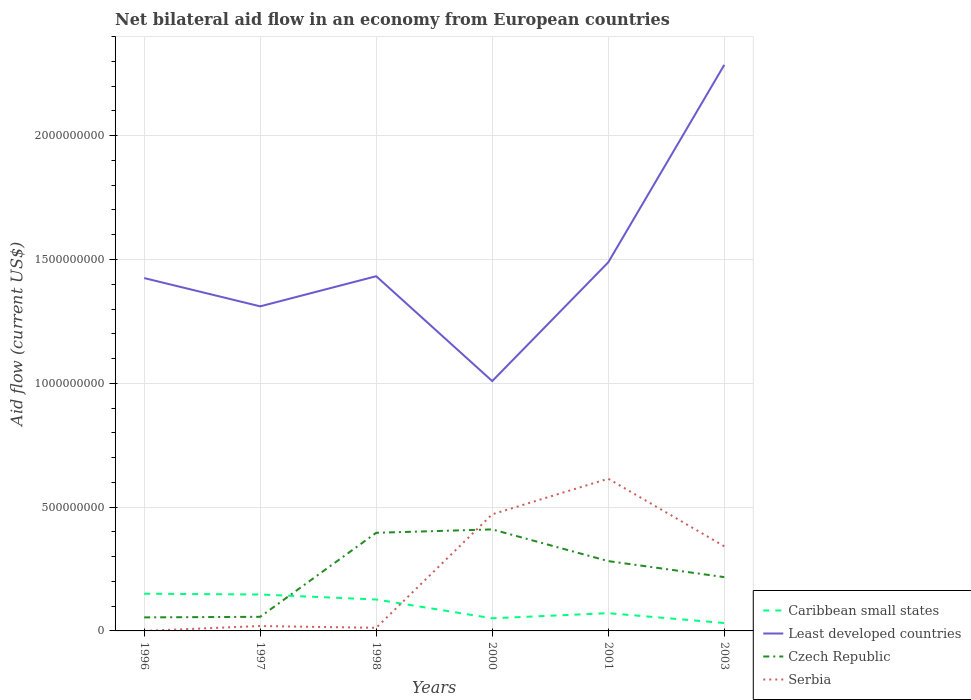Does the line corresponding to Least developed countries intersect with the line corresponding to Caribbean small states?
Offer a terse response. No. Is the number of lines equal to the number of legend labels?
Your answer should be compact. Yes. Across all years, what is the maximum net bilateral aid flow in Serbia?
Provide a succinct answer. 9.00e+04. What is the total net bilateral aid flow in Czech Republic in the graph?
Ensure brevity in your answer.  -2.27e+08. What is the difference between the highest and the second highest net bilateral aid flow in Serbia?
Make the answer very short. 6.15e+08. What is the difference between the highest and the lowest net bilateral aid flow in Serbia?
Provide a succinct answer. 3. How many years are there in the graph?
Offer a very short reply. 6. Does the graph contain grids?
Offer a very short reply. Yes. Where does the legend appear in the graph?
Your answer should be very brief. Bottom right. How many legend labels are there?
Ensure brevity in your answer.  4. What is the title of the graph?
Your answer should be very brief. Net bilateral aid flow in an economy from European countries. Does "New Zealand" appear as one of the legend labels in the graph?
Offer a terse response. No. What is the label or title of the Y-axis?
Your response must be concise. Aid flow (current US$). What is the Aid flow (current US$) in Caribbean small states in 1996?
Your response must be concise. 1.50e+08. What is the Aid flow (current US$) of Least developed countries in 1996?
Give a very brief answer. 1.42e+09. What is the Aid flow (current US$) of Czech Republic in 1996?
Keep it short and to the point. 5.46e+07. What is the Aid flow (current US$) in Serbia in 1996?
Keep it short and to the point. 9.00e+04. What is the Aid flow (current US$) of Caribbean small states in 1997?
Provide a succinct answer. 1.47e+08. What is the Aid flow (current US$) of Least developed countries in 1997?
Keep it short and to the point. 1.31e+09. What is the Aid flow (current US$) of Czech Republic in 1997?
Ensure brevity in your answer.  5.70e+07. What is the Aid flow (current US$) of Serbia in 1997?
Provide a succinct answer. 1.98e+07. What is the Aid flow (current US$) in Caribbean small states in 1998?
Provide a short and direct response. 1.27e+08. What is the Aid flow (current US$) in Least developed countries in 1998?
Keep it short and to the point. 1.43e+09. What is the Aid flow (current US$) in Czech Republic in 1998?
Offer a very short reply. 3.96e+08. What is the Aid flow (current US$) in Serbia in 1998?
Give a very brief answer. 1.26e+07. What is the Aid flow (current US$) in Caribbean small states in 2000?
Ensure brevity in your answer.  5.10e+07. What is the Aid flow (current US$) of Least developed countries in 2000?
Ensure brevity in your answer.  1.01e+09. What is the Aid flow (current US$) in Czech Republic in 2000?
Your answer should be very brief. 4.10e+08. What is the Aid flow (current US$) of Serbia in 2000?
Give a very brief answer. 4.71e+08. What is the Aid flow (current US$) of Caribbean small states in 2001?
Provide a succinct answer. 7.17e+07. What is the Aid flow (current US$) in Least developed countries in 2001?
Your response must be concise. 1.49e+09. What is the Aid flow (current US$) of Czech Republic in 2001?
Keep it short and to the point. 2.82e+08. What is the Aid flow (current US$) of Serbia in 2001?
Your response must be concise. 6.15e+08. What is the Aid flow (current US$) of Caribbean small states in 2003?
Your answer should be very brief. 3.19e+07. What is the Aid flow (current US$) of Least developed countries in 2003?
Make the answer very short. 2.29e+09. What is the Aid flow (current US$) of Czech Republic in 2003?
Offer a very short reply. 2.17e+08. What is the Aid flow (current US$) of Serbia in 2003?
Your answer should be very brief. 3.42e+08. Across all years, what is the maximum Aid flow (current US$) in Caribbean small states?
Provide a short and direct response. 1.50e+08. Across all years, what is the maximum Aid flow (current US$) in Least developed countries?
Provide a short and direct response. 2.29e+09. Across all years, what is the maximum Aid flow (current US$) in Czech Republic?
Provide a succinct answer. 4.10e+08. Across all years, what is the maximum Aid flow (current US$) of Serbia?
Ensure brevity in your answer.  6.15e+08. Across all years, what is the minimum Aid flow (current US$) of Caribbean small states?
Make the answer very short. 3.19e+07. Across all years, what is the minimum Aid flow (current US$) in Least developed countries?
Offer a terse response. 1.01e+09. Across all years, what is the minimum Aid flow (current US$) in Czech Republic?
Offer a very short reply. 5.46e+07. Across all years, what is the minimum Aid flow (current US$) in Serbia?
Ensure brevity in your answer.  9.00e+04. What is the total Aid flow (current US$) in Caribbean small states in the graph?
Offer a terse response. 5.79e+08. What is the total Aid flow (current US$) of Least developed countries in the graph?
Your response must be concise. 8.95e+09. What is the total Aid flow (current US$) of Czech Republic in the graph?
Your answer should be very brief. 1.42e+09. What is the total Aid flow (current US$) of Serbia in the graph?
Provide a short and direct response. 1.46e+09. What is the difference between the Aid flow (current US$) of Caribbean small states in 1996 and that in 1997?
Keep it short and to the point. 3.18e+06. What is the difference between the Aid flow (current US$) in Least developed countries in 1996 and that in 1997?
Give a very brief answer. 1.14e+08. What is the difference between the Aid flow (current US$) of Czech Republic in 1996 and that in 1997?
Provide a short and direct response. -2.37e+06. What is the difference between the Aid flow (current US$) of Serbia in 1996 and that in 1997?
Make the answer very short. -1.97e+07. What is the difference between the Aid flow (current US$) in Caribbean small states in 1996 and that in 1998?
Provide a succinct answer. 2.33e+07. What is the difference between the Aid flow (current US$) in Least developed countries in 1996 and that in 1998?
Your answer should be very brief. -7.51e+06. What is the difference between the Aid flow (current US$) of Czech Republic in 1996 and that in 1998?
Offer a very short reply. -3.42e+08. What is the difference between the Aid flow (current US$) in Serbia in 1996 and that in 1998?
Offer a terse response. -1.25e+07. What is the difference between the Aid flow (current US$) of Caribbean small states in 1996 and that in 2000?
Offer a terse response. 9.92e+07. What is the difference between the Aid flow (current US$) in Least developed countries in 1996 and that in 2000?
Provide a succinct answer. 4.16e+08. What is the difference between the Aid flow (current US$) in Czech Republic in 1996 and that in 2000?
Your answer should be compact. -3.55e+08. What is the difference between the Aid flow (current US$) of Serbia in 1996 and that in 2000?
Your response must be concise. -4.71e+08. What is the difference between the Aid flow (current US$) in Caribbean small states in 1996 and that in 2001?
Provide a short and direct response. 7.85e+07. What is the difference between the Aid flow (current US$) of Least developed countries in 1996 and that in 2001?
Keep it short and to the point. -6.36e+07. What is the difference between the Aid flow (current US$) in Czech Republic in 1996 and that in 2001?
Your response must be concise. -2.27e+08. What is the difference between the Aid flow (current US$) of Serbia in 1996 and that in 2001?
Provide a short and direct response. -6.15e+08. What is the difference between the Aid flow (current US$) of Caribbean small states in 1996 and that in 2003?
Your answer should be very brief. 1.18e+08. What is the difference between the Aid flow (current US$) in Least developed countries in 1996 and that in 2003?
Give a very brief answer. -8.61e+08. What is the difference between the Aid flow (current US$) in Czech Republic in 1996 and that in 2003?
Your answer should be very brief. -1.63e+08. What is the difference between the Aid flow (current US$) of Serbia in 1996 and that in 2003?
Give a very brief answer. -3.42e+08. What is the difference between the Aid flow (current US$) of Caribbean small states in 1997 and that in 1998?
Your answer should be compact. 2.02e+07. What is the difference between the Aid flow (current US$) in Least developed countries in 1997 and that in 1998?
Your answer should be compact. -1.22e+08. What is the difference between the Aid flow (current US$) in Czech Republic in 1997 and that in 1998?
Your response must be concise. -3.39e+08. What is the difference between the Aid flow (current US$) of Serbia in 1997 and that in 1998?
Your response must be concise. 7.20e+06. What is the difference between the Aid flow (current US$) of Caribbean small states in 1997 and that in 2000?
Your response must be concise. 9.60e+07. What is the difference between the Aid flow (current US$) of Least developed countries in 1997 and that in 2000?
Your answer should be very brief. 3.02e+08. What is the difference between the Aid flow (current US$) in Czech Republic in 1997 and that in 2000?
Offer a very short reply. -3.53e+08. What is the difference between the Aid flow (current US$) in Serbia in 1997 and that in 2000?
Give a very brief answer. -4.51e+08. What is the difference between the Aid flow (current US$) in Caribbean small states in 1997 and that in 2001?
Offer a very short reply. 7.54e+07. What is the difference between the Aid flow (current US$) in Least developed countries in 1997 and that in 2001?
Provide a succinct answer. -1.78e+08. What is the difference between the Aid flow (current US$) of Czech Republic in 1997 and that in 2001?
Give a very brief answer. -2.25e+08. What is the difference between the Aid flow (current US$) of Serbia in 1997 and that in 2001?
Keep it short and to the point. -5.95e+08. What is the difference between the Aid flow (current US$) of Caribbean small states in 1997 and that in 2003?
Ensure brevity in your answer.  1.15e+08. What is the difference between the Aid flow (current US$) of Least developed countries in 1997 and that in 2003?
Your response must be concise. -9.75e+08. What is the difference between the Aid flow (current US$) of Czech Republic in 1997 and that in 2003?
Your answer should be very brief. -1.60e+08. What is the difference between the Aid flow (current US$) of Serbia in 1997 and that in 2003?
Your answer should be compact. -3.22e+08. What is the difference between the Aid flow (current US$) of Caribbean small states in 1998 and that in 2000?
Give a very brief answer. 7.59e+07. What is the difference between the Aid flow (current US$) in Least developed countries in 1998 and that in 2000?
Your answer should be very brief. 4.23e+08. What is the difference between the Aid flow (current US$) of Czech Republic in 1998 and that in 2000?
Your answer should be very brief. -1.36e+07. What is the difference between the Aid flow (current US$) in Serbia in 1998 and that in 2000?
Make the answer very short. -4.58e+08. What is the difference between the Aid flow (current US$) of Caribbean small states in 1998 and that in 2001?
Give a very brief answer. 5.52e+07. What is the difference between the Aid flow (current US$) in Least developed countries in 1998 and that in 2001?
Provide a succinct answer. -5.61e+07. What is the difference between the Aid flow (current US$) of Czech Republic in 1998 and that in 2001?
Your answer should be compact. 1.14e+08. What is the difference between the Aid flow (current US$) in Serbia in 1998 and that in 2001?
Offer a terse response. -6.02e+08. What is the difference between the Aid flow (current US$) in Caribbean small states in 1998 and that in 2003?
Provide a succinct answer. 9.50e+07. What is the difference between the Aid flow (current US$) of Least developed countries in 1998 and that in 2003?
Provide a short and direct response. -8.53e+08. What is the difference between the Aid flow (current US$) in Czech Republic in 1998 and that in 2003?
Offer a terse response. 1.79e+08. What is the difference between the Aid flow (current US$) in Serbia in 1998 and that in 2003?
Your response must be concise. -3.29e+08. What is the difference between the Aid flow (current US$) in Caribbean small states in 2000 and that in 2001?
Keep it short and to the point. -2.07e+07. What is the difference between the Aid flow (current US$) in Least developed countries in 2000 and that in 2001?
Your answer should be very brief. -4.80e+08. What is the difference between the Aid flow (current US$) in Czech Republic in 2000 and that in 2001?
Make the answer very short. 1.28e+08. What is the difference between the Aid flow (current US$) in Serbia in 2000 and that in 2001?
Make the answer very short. -1.44e+08. What is the difference between the Aid flow (current US$) in Caribbean small states in 2000 and that in 2003?
Offer a terse response. 1.91e+07. What is the difference between the Aid flow (current US$) in Least developed countries in 2000 and that in 2003?
Your response must be concise. -1.28e+09. What is the difference between the Aid flow (current US$) of Czech Republic in 2000 and that in 2003?
Offer a terse response. 1.93e+08. What is the difference between the Aid flow (current US$) in Serbia in 2000 and that in 2003?
Your response must be concise. 1.29e+08. What is the difference between the Aid flow (current US$) of Caribbean small states in 2001 and that in 2003?
Keep it short and to the point. 3.98e+07. What is the difference between the Aid flow (current US$) in Least developed countries in 2001 and that in 2003?
Ensure brevity in your answer.  -7.97e+08. What is the difference between the Aid flow (current US$) of Czech Republic in 2001 and that in 2003?
Provide a succinct answer. 6.47e+07. What is the difference between the Aid flow (current US$) in Serbia in 2001 and that in 2003?
Provide a succinct answer. 2.73e+08. What is the difference between the Aid flow (current US$) in Caribbean small states in 1996 and the Aid flow (current US$) in Least developed countries in 1997?
Provide a succinct answer. -1.16e+09. What is the difference between the Aid flow (current US$) of Caribbean small states in 1996 and the Aid flow (current US$) of Czech Republic in 1997?
Your answer should be compact. 9.32e+07. What is the difference between the Aid flow (current US$) of Caribbean small states in 1996 and the Aid flow (current US$) of Serbia in 1997?
Provide a succinct answer. 1.30e+08. What is the difference between the Aid flow (current US$) in Least developed countries in 1996 and the Aid flow (current US$) in Czech Republic in 1997?
Provide a succinct answer. 1.37e+09. What is the difference between the Aid flow (current US$) in Least developed countries in 1996 and the Aid flow (current US$) in Serbia in 1997?
Make the answer very short. 1.41e+09. What is the difference between the Aid flow (current US$) of Czech Republic in 1996 and the Aid flow (current US$) of Serbia in 1997?
Make the answer very short. 3.49e+07. What is the difference between the Aid flow (current US$) of Caribbean small states in 1996 and the Aid flow (current US$) of Least developed countries in 1998?
Make the answer very short. -1.28e+09. What is the difference between the Aid flow (current US$) in Caribbean small states in 1996 and the Aid flow (current US$) in Czech Republic in 1998?
Give a very brief answer. -2.46e+08. What is the difference between the Aid flow (current US$) of Caribbean small states in 1996 and the Aid flow (current US$) of Serbia in 1998?
Give a very brief answer. 1.38e+08. What is the difference between the Aid flow (current US$) in Least developed countries in 1996 and the Aid flow (current US$) in Czech Republic in 1998?
Your answer should be very brief. 1.03e+09. What is the difference between the Aid flow (current US$) in Least developed countries in 1996 and the Aid flow (current US$) in Serbia in 1998?
Offer a very short reply. 1.41e+09. What is the difference between the Aid flow (current US$) in Czech Republic in 1996 and the Aid flow (current US$) in Serbia in 1998?
Your answer should be compact. 4.21e+07. What is the difference between the Aid flow (current US$) of Caribbean small states in 1996 and the Aid flow (current US$) of Least developed countries in 2000?
Provide a succinct answer. -8.59e+08. What is the difference between the Aid flow (current US$) in Caribbean small states in 1996 and the Aid flow (current US$) in Czech Republic in 2000?
Offer a terse response. -2.60e+08. What is the difference between the Aid flow (current US$) in Caribbean small states in 1996 and the Aid flow (current US$) in Serbia in 2000?
Ensure brevity in your answer.  -3.21e+08. What is the difference between the Aid flow (current US$) in Least developed countries in 1996 and the Aid flow (current US$) in Czech Republic in 2000?
Your answer should be very brief. 1.01e+09. What is the difference between the Aid flow (current US$) of Least developed countries in 1996 and the Aid flow (current US$) of Serbia in 2000?
Provide a short and direct response. 9.54e+08. What is the difference between the Aid flow (current US$) of Czech Republic in 1996 and the Aid flow (current US$) of Serbia in 2000?
Your answer should be compact. -4.16e+08. What is the difference between the Aid flow (current US$) in Caribbean small states in 1996 and the Aid flow (current US$) in Least developed countries in 2001?
Give a very brief answer. -1.34e+09. What is the difference between the Aid flow (current US$) of Caribbean small states in 1996 and the Aid flow (current US$) of Czech Republic in 2001?
Provide a succinct answer. -1.32e+08. What is the difference between the Aid flow (current US$) of Caribbean small states in 1996 and the Aid flow (current US$) of Serbia in 2001?
Provide a succinct answer. -4.64e+08. What is the difference between the Aid flow (current US$) of Least developed countries in 1996 and the Aid flow (current US$) of Czech Republic in 2001?
Provide a short and direct response. 1.14e+09. What is the difference between the Aid flow (current US$) of Least developed countries in 1996 and the Aid flow (current US$) of Serbia in 2001?
Ensure brevity in your answer.  8.10e+08. What is the difference between the Aid flow (current US$) in Czech Republic in 1996 and the Aid flow (current US$) in Serbia in 2001?
Keep it short and to the point. -5.60e+08. What is the difference between the Aid flow (current US$) of Caribbean small states in 1996 and the Aid flow (current US$) of Least developed countries in 2003?
Provide a short and direct response. -2.14e+09. What is the difference between the Aid flow (current US$) in Caribbean small states in 1996 and the Aid flow (current US$) in Czech Republic in 2003?
Make the answer very short. -6.70e+07. What is the difference between the Aid flow (current US$) in Caribbean small states in 1996 and the Aid flow (current US$) in Serbia in 2003?
Provide a succinct answer. -1.92e+08. What is the difference between the Aid flow (current US$) of Least developed countries in 1996 and the Aid flow (current US$) of Czech Republic in 2003?
Provide a succinct answer. 1.21e+09. What is the difference between the Aid flow (current US$) of Least developed countries in 1996 and the Aid flow (current US$) of Serbia in 2003?
Keep it short and to the point. 1.08e+09. What is the difference between the Aid flow (current US$) of Czech Republic in 1996 and the Aid flow (current US$) of Serbia in 2003?
Make the answer very short. -2.87e+08. What is the difference between the Aid flow (current US$) of Caribbean small states in 1997 and the Aid flow (current US$) of Least developed countries in 1998?
Offer a very short reply. -1.29e+09. What is the difference between the Aid flow (current US$) of Caribbean small states in 1997 and the Aid flow (current US$) of Czech Republic in 1998?
Provide a succinct answer. -2.49e+08. What is the difference between the Aid flow (current US$) in Caribbean small states in 1997 and the Aid flow (current US$) in Serbia in 1998?
Your answer should be very brief. 1.34e+08. What is the difference between the Aid flow (current US$) of Least developed countries in 1997 and the Aid flow (current US$) of Czech Republic in 1998?
Your answer should be very brief. 9.14e+08. What is the difference between the Aid flow (current US$) in Least developed countries in 1997 and the Aid flow (current US$) in Serbia in 1998?
Provide a succinct answer. 1.30e+09. What is the difference between the Aid flow (current US$) of Czech Republic in 1997 and the Aid flow (current US$) of Serbia in 1998?
Provide a short and direct response. 4.44e+07. What is the difference between the Aid flow (current US$) in Caribbean small states in 1997 and the Aid flow (current US$) in Least developed countries in 2000?
Ensure brevity in your answer.  -8.62e+08. What is the difference between the Aid flow (current US$) in Caribbean small states in 1997 and the Aid flow (current US$) in Czech Republic in 2000?
Your answer should be very brief. -2.63e+08. What is the difference between the Aid flow (current US$) of Caribbean small states in 1997 and the Aid flow (current US$) of Serbia in 2000?
Your answer should be compact. -3.24e+08. What is the difference between the Aid flow (current US$) in Least developed countries in 1997 and the Aid flow (current US$) in Czech Republic in 2000?
Make the answer very short. 9.01e+08. What is the difference between the Aid flow (current US$) of Least developed countries in 1997 and the Aid flow (current US$) of Serbia in 2000?
Provide a succinct answer. 8.40e+08. What is the difference between the Aid flow (current US$) in Czech Republic in 1997 and the Aid flow (current US$) in Serbia in 2000?
Offer a terse response. -4.14e+08. What is the difference between the Aid flow (current US$) of Caribbean small states in 1997 and the Aid flow (current US$) of Least developed countries in 2001?
Make the answer very short. -1.34e+09. What is the difference between the Aid flow (current US$) of Caribbean small states in 1997 and the Aid flow (current US$) of Czech Republic in 2001?
Your answer should be very brief. -1.35e+08. What is the difference between the Aid flow (current US$) of Caribbean small states in 1997 and the Aid flow (current US$) of Serbia in 2001?
Ensure brevity in your answer.  -4.68e+08. What is the difference between the Aid flow (current US$) in Least developed countries in 1997 and the Aid flow (current US$) in Czech Republic in 2001?
Make the answer very short. 1.03e+09. What is the difference between the Aid flow (current US$) in Least developed countries in 1997 and the Aid flow (current US$) in Serbia in 2001?
Give a very brief answer. 6.96e+08. What is the difference between the Aid flow (current US$) of Czech Republic in 1997 and the Aid flow (current US$) of Serbia in 2001?
Keep it short and to the point. -5.58e+08. What is the difference between the Aid flow (current US$) in Caribbean small states in 1997 and the Aid flow (current US$) in Least developed countries in 2003?
Provide a succinct answer. -2.14e+09. What is the difference between the Aid flow (current US$) in Caribbean small states in 1997 and the Aid flow (current US$) in Czech Republic in 2003?
Give a very brief answer. -7.02e+07. What is the difference between the Aid flow (current US$) in Caribbean small states in 1997 and the Aid flow (current US$) in Serbia in 2003?
Provide a succinct answer. -1.95e+08. What is the difference between the Aid flow (current US$) of Least developed countries in 1997 and the Aid flow (current US$) of Czech Republic in 2003?
Offer a very short reply. 1.09e+09. What is the difference between the Aid flow (current US$) of Least developed countries in 1997 and the Aid flow (current US$) of Serbia in 2003?
Ensure brevity in your answer.  9.69e+08. What is the difference between the Aid flow (current US$) in Czech Republic in 1997 and the Aid flow (current US$) in Serbia in 2003?
Your answer should be very brief. -2.85e+08. What is the difference between the Aid flow (current US$) of Caribbean small states in 1998 and the Aid flow (current US$) of Least developed countries in 2000?
Make the answer very short. -8.82e+08. What is the difference between the Aid flow (current US$) of Caribbean small states in 1998 and the Aid flow (current US$) of Czech Republic in 2000?
Ensure brevity in your answer.  -2.83e+08. What is the difference between the Aid flow (current US$) in Caribbean small states in 1998 and the Aid flow (current US$) in Serbia in 2000?
Offer a very short reply. -3.44e+08. What is the difference between the Aid flow (current US$) in Least developed countries in 1998 and the Aid flow (current US$) in Czech Republic in 2000?
Your response must be concise. 1.02e+09. What is the difference between the Aid flow (current US$) of Least developed countries in 1998 and the Aid flow (current US$) of Serbia in 2000?
Provide a short and direct response. 9.61e+08. What is the difference between the Aid flow (current US$) of Czech Republic in 1998 and the Aid flow (current US$) of Serbia in 2000?
Offer a terse response. -7.46e+07. What is the difference between the Aid flow (current US$) in Caribbean small states in 1998 and the Aid flow (current US$) in Least developed countries in 2001?
Provide a succinct answer. -1.36e+09. What is the difference between the Aid flow (current US$) of Caribbean small states in 1998 and the Aid flow (current US$) of Czech Republic in 2001?
Your answer should be very brief. -1.55e+08. What is the difference between the Aid flow (current US$) of Caribbean small states in 1998 and the Aid flow (current US$) of Serbia in 2001?
Keep it short and to the point. -4.88e+08. What is the difference between the Aid flow (current US$) in Least developed countries in 1998 and the Aid flow (current US$) in Czech Republic in 2001?
Offer a terse response. 1.15e+09. What is the difference between the Aid flow (current US$) of Least developed countries in 1998 and the Aid flow (current US$) of Serbia in 2001?
Your response must be concise. 8.18e+08. What is the difference between the Aid flow (current US$) in Czech Republic in 1998 and the Aid flow (current US$) in Serbia in 2001?
Provide a succinct answer. -2.18e+08. What is the difference between the Aid flow (current US$) in Caribbean small states in 1998 and the Aid flow (current US$) in Least developed countries in 2003?
Give a very brief answer. -2.16e+09. What is the difference between the Aid flow (current US$) in Caribbean small states in 1998 and the Aid flow (current US$) in Czech Republic in 2003?
Your answer should be compact. -9.04e+07. What is the difference between the Aid flow (current US$) of Caribbean small states in 1998 and the Aid flow (current US$) of Serbia in 2003?
Your answer should be compact. -2.15e+08. What is the difference between the Aid flow (current US$) of Least developed countries in 1998 and the Aid flow (current US$) of Czech Republic in 2003?
Give a very brief answer. 1.22e+09. What is the difference between the Aid flow (current US$) of Least developed countries in 1998 and the Aid flow (current US$) of Serbia in 2003?
Keep it short and to the point. 1.09e+09. What is the difference between the Aid flow (current US$) in Czech Republic in 1998 and the Aid flow (current US$) in Serbia in 2003?
Offer a very short reply. 5.45e+07. What is the difference between the Aid flow (current US$) in Caribbean small states in 2000 and the Aid flow (current US$) in Least developed countries in 2001?
Keep it short and to the point. -1.44e+09. What is the difference between the Aid flow (current US$) in Caribbean small states in 2000 and the Aid flow (current US$) in Czech Republic in 2001?
Ensure brevity in your answer.  -2.31e+08. What is the difference between the Aid flow (current US$) of Caribbean small states in 2000 and the Aid flow (current US$) of Serbia in 2001?
Provide a succinct answer. -5.64e+08. What is the difference between the Aid flow (current US$) in Least developed countries in 2000 and the Aid flow (current US$) in Czech Republic in 2001?
Your answer should be compact. 7.27e+08. What is the difference between the Aid flow (current US$) in Least developed countries in 2000 and the Aid flow (current US$) in Serbia in 2001?
Your answer should be compact. 3.94e+08. What is the difference between the Aid flow (current US$) of Czech Republic in 2000 and the Aid flow (current US$) of Serbia in 2001?
Provide a short and direct response. -2.05e+08. What is the difference between the Aid flow (current US$) in Caribbean small states in 2000 and the Aid flow (current US$) in Least developed countries in 2003?
Offer a very short reply. -2.23e+09. What is the difference between the Aid flow (current US$) of Caribbean small states in 2000 and the Aid flow (current US$) of Czech Republic in 2003?
Your answer should be very brief. -1.66e+08. What is the difference between the Aid flow (current US$) in Caribbean small states in 2000 and the Aid flow (current US$) in Serbia in 2003?
Offer a very short reply. -2.91e+08. What is the difference between the Aid flow (current US$) of Least developed countries in 2000 and the Aid flow (current US$) of Czech Republic in 2003?
Your answer should be compact. 7.92e+08. What is the difference between the Aid flow (current US$) of Least developed countries in 2000 and the Aid flow (current US$) of Serbia in 2003?
Provide a short and direct response. 6.67e+08. What is the difference between the Aid flow (current US$) of Czech Republic in 2000 and the Aid flow (current US$) of Serbia in 2003?
Your answer should be very brief. 6.82e+07. What is the difference between the Aid flow (current US$) of Caribbean small states in 2001 and the Aid flow (current US$) of Least developed countries in 2003?
Your answer should be very brief. -2.21e+09. What is the difference between the Aid flow (current US$) in Caribbean small states in 2001 and the Aid flow (current US$) in Czech Republic in 2003?
Provide a short and direct response. -1.46e+08. What is the difference between the Aid flow (current US$) of Caribbean small states in 2001 and the Aid flow (current US$) of Serbia in 2003?
Keep it short and to the point. -2.70e+08. What is the difference between the Aid flow (current US$) in Least developed countries in 2001 and the Aid flow (current US$) in Czech Republic in 2003?
Provide a succinct answer. 1.27e+09. What is the difference between the Aid flow (current US$) in Least developed countries in 2001 and the Aid flow (current US$) in Serbia in 2003?
Your answer should be very brief. 1.15e+09. What is the difference between the Aid flow (current US$) in Czech Republic in 2001 and the Aid flow (current US$) in Serbia in 2003?
Offer a very short reply. -5.98e+07. What is the average Aid flow (current US$) of Caribbean small states per year?
Ensure brevity in your answer.  9.65e+07. What is the average Aid flow (current US$) of Least developed countries per year?
Provide a succinct answer. 1.49e+09. What is the average Aid flow (current US$) of Czech Republic per year?
Offer a very short reply. 2.36e+08. What is the average Aid flow (current US$) in Serbia per year?
Offer a terse response. 2.43e+08. In the year 1996, what is the difference between the Aid flow (current US$) of Caribbean small states and Aid flow (current US$) of Least developed countries?
Provide a short and direct response. -1.27e+09. In the year 1996, what is the difference between the Aid flow (current US$) of Caribbean small states and Aid flow (current US$) of Czech Republic?
Ensure brevity in your answer.  9.56e+07. In the year 1996, what is the difference between the Aid flow (current US$) of Caribbean small states and Aid flow (current US$) of Serbia?
Ensure brevity in your answer.  1.50e+08. In the year 1996, what is the difference between the Aid flow (current US$) of Least developed countries and Aid flow (current US$) of Czech Republic?
Offer a terse response. 1.37e+09. In the year 1996, what is the difference between the Aid flow (current US$) in Least developed countries and Aid flow (current US$) in Serbia?
Make the answer very short. 1.42e+09. In the year 1996, what is the difference between the Aid flow (current US$) in Czech Republic and Aid flow (current US$) in Serbia?
Ensure brevity in your answer.  5.45e+07. In the year 1997, what is the difference between the Aid flow (current US$) in Caribbean small states and Aid flow (current US$) in Least developed countries?
Provide a succinct answer. -1.16e+09. In the year 1997, what is the difference between the Aid flow (current US$) in Caribbean small states and Aid flow (current US$) in Czech Republic?
Keep it short and to the point. 9.01e+07. In the year 1997, what is the difference between the Aid flow (current US$) in Caribbean small states and Aid flow (current US$) in Serbia?
Offer a terse response. 1.27e+08. In the year 1997, what is the difference between the Aid flow (current US$) of Least developed countries and Aid flow (current US$) of Czech Republic?
Give a very brief answer. 1.25e+09. In the year 1997, what is the difference between the Aid flow (current US$) in Least developed countries and Aid flow (current US$) in Serbia?
Your answer should be compact. 1.29e+09. In the year 1997, what is the difference between the Aid flow (current US$) of Czech Republic and Aid flow (current US$) of Serbia?
Offer a terse response. 3.72e+07. In the year 1998, what is the difference between the Aid flow (current US$) of Caribbean small states and Aid flow (current US$) of Least developed countries?
Keep it short and to the point. -1.31e+09. In the year 1998, what is the difference between the Aid flow (current US$) of Caribbean small states and Aid flow (current US$) of Czech Republic?
Offer a very short reply. -2.69e+08. In the year 1998, what is the difference between the Aid flow (current US$) of Caribbean small states and Aid flow (current US$) of Serbia?
Your response must be concise. 1.14e+08. In the year 1998, what is the difference between the Aid flow (current US$) in Least developed countries and Aid flow (current US$) in Czech Republic?
Provide a succinct answer. 1.04e+09. In the year 1998, what is the difference between the Aid flow (current US$) in Least developed countries and Aid flow (current US$) in Serbia?
Provide a succinct answer. 1.42e+09. In the year 1998, what is the difference between the Aid flow (current US$) in Czech Republic and Aid flow (current US$) in Serbia?
Offer a terse response. 3.84e+08. In the year 2000, what is the difference between the Aid flow (current US$) in Caribbean small states and Aid flow (current US$) in Least developed countries?
Your response must be concise. -9.58e+08. In the year 2000, what is the difference between the Aid flow (current US$) in Caribbean small states and Aid flow (current US$) in Czech Republic?
Your answer should be very brief. -3.59e+08. In the year 2000, what is the difference between the Aid flow (current US$) in Caribbean small states and Aid flow (current US$) in Serbia?
Keep it short and to the point. -4.20e+08. In the year 2000, what is the difference between the Aid flow (current US$) of Least developed countries and Aid flow (current US$) of Czech Republic?
Give a very brief answer. 5.99e+08. In the year 2000, what is the difference between the Aid flow (current US$) of Least developed countries and Aid flow (current US$) of Serbia?
Your answer should be very brief. 5.38e+08. In the year 2000, what is the difference between the Aid flow (current US$) of Czech Republic and Aid flow (current US$) of Serbia?
Make the answer very short. -6.10e+07. In the year 2001, what is the difference between the Aid flow (current US$) of Caribbean small states and Aid flow (current US$) of Least developed countries?
Provide a short and direct response. -1.42e+09. In the year 2001, what is the difference between the Aid flow (current US$) in Caribbean small states and Aid flow (current US$) in Czech Republic?
Your answer should be compact. -2.10e+08. In the year 2001, what is the difference between the Aid flow (current US$) in Caribbean small states and Aid flow (current US$) in Serbia?
Keep it short and to the point. -5.43e+08. In the year 2001, what is the difference between the Aid flow (current US$) in Least developed countries and Aid flow (current US$) in Czech Republic?
Provide a succinct answer. 1.21e+09. In the year 2001, what is the difference between the Aid flow (current US$) in Least developed countries and Aid flow (current US$) in Serbia?
Ensure brevity in your answer.  8.74e+08. In the year 2001, what is the difference between the Aid flow (current US$) in Czech Republic and Aid flow (current US$) in Serbia?
Offer a terse response. -3.33e+08. In the year 2003, what is the difference between the Aid flow (current US$) of Caribbean small states and Aid flow (current US$) of Least developed countries?
Keep it short and to the point. -2.25e+09. In the year 2003, what is the difference between the Aid flow (current US$) in Caribbean small states and Aid flow (current US$) in Czech Republic?
Your answer should be very brief. -1.85e+08. In the year 2003, what is the difference between the Aid flow (current US$) in Caribbean small states and Aid flow (current US$) in Serbia?
Offer a terse response. -3.10e+08. In the year 2003, what is the difference between the Aid flow (current US$) in Least developed countries and Aid flow (current US$) in Czech Republic?
Offer a terse response. 2.07e+09. In the year 2003, what is the difference between the Aid flow (current US$) of Least developed countries and Aid flow (current US$) of Serbia?
Your response must be concise. 1.94e+09. In the year 2003, what is the difference between the Aid flow (current US$) in Czech Republic and Aid flow (current US$) in Serbia?
Make the answer very short. -1.24e+08. What is the ratio of the Aid flow (current US$) in Caribbean small states in 1996 to that in 1997?
Give a very brief answer. 1.02. What is the ratio of the Aid flow (current US$) in Least developed countries in 1996 to that in 1997?
Offer a terse response. 1.09. What is the ratio of the Aid flow (current US$) of Czech Republic in 1996 to that in 1997?
Give a very brief answer. 0.96. What is the ratio of the Aid flow (current US$) of Serbia in 1996 to that in 1997?
Keep it short and to the point. 0. What is the ratio of the Aid flow (current US$) in Caribbean small states in 1996 to that in 1998?
Your response must be concise. 1.18. What is the ratio of the Aid flow (current US$) in Czech Republic in 1996 to that in 1998?
Provide a short and direct response. 0.14. What is the ratio of the Aid flow (current US$) in Serbia in 1996 to that in 1998?
Your response must be concise. 0.01. What is the ratio of the Aid flow (current US$) in Caribbean small states in 1996 to that in 2000?
Your answer should be compact. 2.94. What is the ratio of the Aid flow (current US$) of Least developed countries in 1996 to that in 2000?
Give a very brief answer. 1.41. What is the ratio of the Aid flow (current US$) of Czech Republic in 1996 to that in 2000?
Offer a very short reply. 0.13. What is the ratio of the Aid flow (current US$) of Caribbean small states in 1996 to that in 2001?
Ensure brevity in your answer.  2.1. What is the ratio of the Aid flow (current US$) of Least developed countries in 1996 to that in 2001?
Your answer should be very brief. 0.96. What is the ratio of the Aid flow (current US$) of Czech Republic in 1996 to that in 2001?
Ensure brevity in your answer.  0.19. What is the ratio of the Aid flow (current US$) in Serbia in 1996 to that in 2001?
Your response must be concise. 0. What is the ratio of the Aid flow (current US$) in Caribbean small states in 1996 to that in 2003?
Provide a short and direct response. 4.71. What is the ratio of the Aid flow (current US$) of Least developed countries in 1996 to that in 2003?
Your answer should be very brief. 0.62. What is the ratio of the Aid flow (current US$) in Czech Republic in 1996 to that in 2003?
Give a very brief answer. 0.25. What is the ratio of the Aid flow (current US$) of Serbia in 1996 to that in 2003?
Make the answer very short. 0. What is the ratio of the Aid flow (current US$) in Caribbean small states in 1997 to that in 1998?
Make the answer very short. 1.16. What is the ratio of the Aid flow (current US$) in Least developed countries in 1997 to that in 1998?
Make the answer very short. 0.92. What is the ratio of the Aid flow (current US$) of Czech Republic in 1997 to that in 1998?
Provide a short and direct response. 0.14. What is the ratio of the Aid flow (current US$) in Serbia in 1997 to that in 1998?
Your answer should be compact. 1.57. What is the ratio of the Aid flow (current US$) in Caribbean small states in 1997 to that in 2000?
Your answer should be very brief. 2.88. What is the ratio of the Aid flow (current US$) of Least developed countries in 1997 to that in 2000?
Offer a very short reply. 1.3. What is the ratio of the Aid flow (current US$) of Czech Republic in 1997 to that in 2000?
Provide a short and direct response. 0.14. What is the ratio of the Aid flow (current US$) of Serbia in 1997 to that in 2000?
Give a very brief answer. 0.04. What is the ratio of the Aid flow (current US$) of Caribbean small states in 1997 to that in 2001?
Your response must be concise. 2.05. What is the ratio of the Aid flow (current US$) of Least developed countries in 1997 to that in 2001?
Ensure brevity in your answer.  0.88. What is the ratio of the Aid flow (current US$) of Czech Republic in 1997 to that in 2001?
Make the answer very short. 0.2. What is the ratio of the Aid flow (current US$) in Serbia in 1997 to that in 2001?
Offer a very short reply. 0.03. What is the ratio of the Aid flow (current US$) in Caribbean small states in 1997 to that in 2003?
Your response must be concise. 4.61. What is the ratio of the Aid flow (current US$) in Least developed countries in 1997 to that in 2003?
Make the answer very short. 0.57. What is the ratio of the Aid flow (current US$) in Czech Republic in 1997 to that in 2003?
Keep it short and to the point. 0.26. What is the ratio of the Aid flow (current US$) in Serbia in 1997 to that in 2003?
Give a very brief answer. 0.06. What is the ratio of the Aid flow (current US$) of Caribbean small states in 1998 to that in 2000?
Keep it short and to the point. 2.49. What is the ratio of the Aid flow (current US$) in Least developed countries in 1998 to that in 2000?
Offer a terse response. 1.42. What is the ratio of the Aid flow (current US$) of Czech Republic in 1998 to that in 2000?
Make the answer very short. 0.97. What is the ratio of the Aid flow (current US$) in Serbia in 1998 to that in 2000?
Ensure brevity in your answer.  0.03. What is the ratio of the Aid flow (current US$) in Caribbean small states in 1998 to that in 2001?
Your answer should be very brief. 1.77. What is the ratio of the Aid flow (current US$) in Least developed countries in 1998 to that in 2001?
Keep it short and to the point. 0.96. What is the ratio of the Aid flow (current US$) of Czech Republic in 1998 to that in 2001?
Your answer should be compact. 1.41. What is the ratio of the Aid flow (current US$) of Serbia in 1998 to that in 2001?
Your answer should be compact. 0.02. What is the ratio of the Aid flow (current US$) of Caribbean small states in 1998 to that in 2003?
Give a very brief answer. 3.98. What is the ratio of the Aid flow (current US$) of Least developed countries in 1998 to that in 2003?
Your answer should be very brief. 0.63. What is the ratio of the Aid flow (current US$) in Czech Republic in 1998 to that in 2003?
Keep it short and to the point. 1.82. What is the ratio of the Aid flow (current US$) of Serbia in 1998 to that in 2003?
Keep it short and to the point. 0.04. What is the ratio of the Aid flow (current US$) of Caribbean small states in 2000 to that in 2001?
Offer a very short reply. 0.71. What is the ratio of the Aid flow (current US$) in Least developed countries in 2000 to that in 2001?
Your answer should be compact. 0.68. What is the ratio of the Aid flow (current US$) of Czech Republic in 2000 to that in 2001?
Provide a short and direct response. 1.45. What is the ratio of the Aid flow (current US$) in Serbia in 2000 to that in 2001?
Offer a terse response. 0.77. What is the ratio of the Aid flow (current US$) in Caribbean small states in 2000 to that in 2003?
Provide a succinct answer. 1.6. What is the ratio of the Aid flow (current US$) in Least developed countries in 2000 to that in 2003?
Ensure brevity in your answer.  0.44. What is the ratio of the Aid flow (current US$) in Czech Republic in 2000 to that in 2003?
Provide a succinct answer. 1.89. What is the ratio of the Aid flow (current US$) of Serbia in 2000 to that in 2003?
Offer a very short reply. 1.38. What is the ratio of the Aid flow (current US$) in Caribbean small states in 2001 to that in 2003?
Give a very brief answer. 2.25. What is the ratio of the Aid flow (current US$) of Least developed countries in 2001 to that in 2003?
Ensure brevity in your answer.  0.65. What is the ratio of the Aid flow (current US$) in Czech Republic in 2001 to that in 2003?
Ensure brevity in your answer.  1.3. What is the ratio of the Aid flow (current US$) of Serbia in 2001 to that in 2003?
Your answer should be compact. 1.8. What is the difference between the highest and the second highest Aid flow (current US$) in Caribbean small states?
Your answer should be compact. 3.18e+06. What is the difference between the highest and the second highest Aid flow (current US$) in Least developed countries?
Offer a very short reply. 7.97e+08. What is the difference between the highest and the second highest Aid flow (current US$) of Czech Republic?
Provide a succinct answer. 1.36e+07. What is the difference between the highest and the second highest Aid flow (current US$) in Serbia?
Ensure brevity in your answer.  1.44e+08. What is the difference between the highest and the lowest Aid flow (current US$) in Caribbean small states?
Keep it short and to the point. 1.18e+08. What is the difference between the highest and the lowest Aid flow (current US$) of Least developed countries?
Your answer should be very brief. 1.28e+09. What is the difference between the highest and the lowest Aid flow (current US$) of Czech Republic?
Ensure brevity in your answer.  3.55e+08. What is the difference between the highest and the lowest Aid flow (current US$) of Serbia?
Your answer should be very brief. 6.15e+08. 